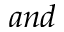<formula> <loc_0><loc_0><loc_500><loc_500>a n d</formula> 